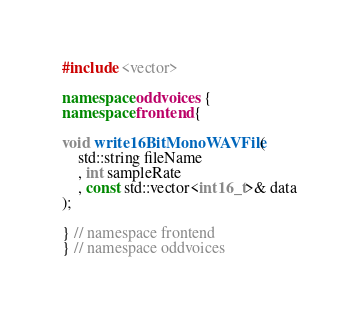Convert code to text. <code><loc_0><loc_0><loc_500><loc_500><_C++_>#include <vector>

namespace oddvoices {
namespace frontend {

void write16BitMonoWAVFile(
    std::string fileName
    , int sampleRate
    , const std::vector<int16_t>& data
);

} // namespace frontend
} // namespace oddvoices
</code> 